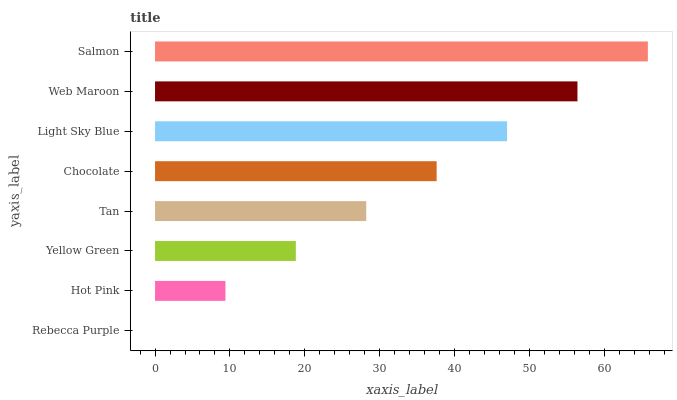Is Rebecca Purple the minimum?
Answer yes or no. Yes. Is Salmon the maximum?
Answer yes or no. Yes. Is Hot Pink the minimum?
Answer yes or no. No. Is Hot Pink the maximum?
Answer yes or no. No. Is Hot Pink greater than Rebecca Purple?
Answer yes or no. Yes. Is Rebecca Purple less than Hot Pink?
Answer yes or no. Yes. Is Rebecca Purple greater than Hot Pink?
Answer yes or no. No. Is Hot Pink less than Rebecca Purple?
Answer yes or no. No. Is Chocolate the high median?
Answer yes or no. Yes. Is Tan the low median?
Answer yes or no. Yes. Is Salmon the high median?
Answer yes or no. No. Is Yellow Green the low median?
Answer yes or no. No. 